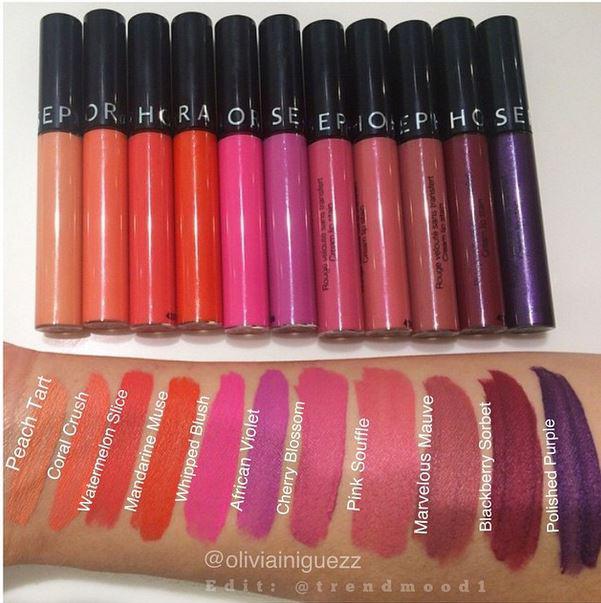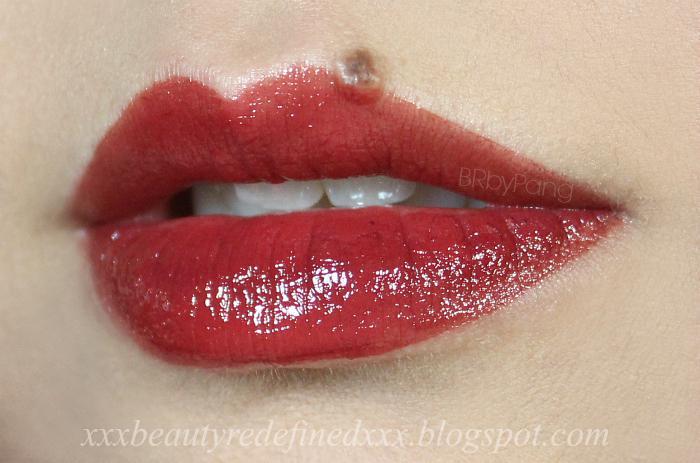The first image is the image on the left, the second image is the image on the right. Examine the images to the left and right. Is the description "Right image shows one pair of tinted lips." accurate? Answer yes or no. Yes. The first image is the image on the left, the second image is the image on the right. Examine the images to the left and right. Is the description "A pair of lips is visible in the right image" accurate? Answer yes or no. Yes. 